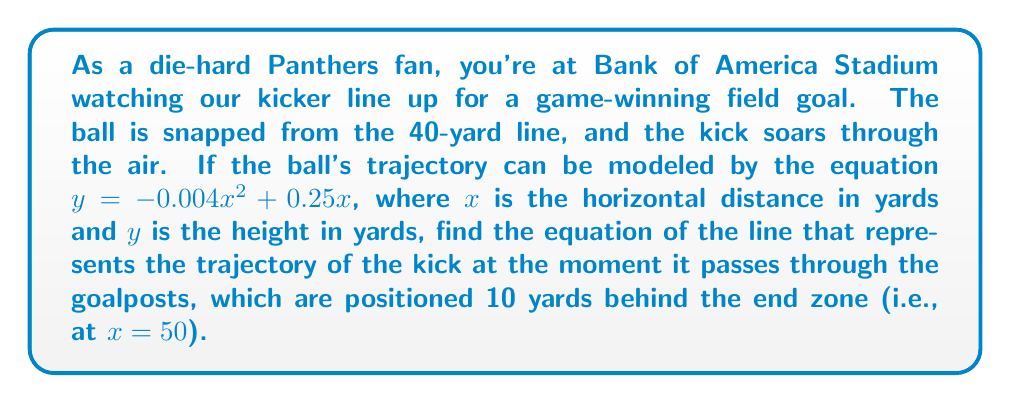Give your solution to this math problem. To find the equation of the line representing the trajectory at a specific point, we need to find the tangent line to the parabola at that point. Here's how we can do this:

1) First, let's find the coordinates of the point where the ball passes through the goalposts:
   At $x = 50$:
   $y = -0.004(50)^2 + 0.25(50) = -10 + 12.5 = 2.5$
   So, the point is $(50, 2.5)$

2) To find the slope of the tangent line, we need to find the derivative of the original function and evaluate it at $x = 50$:
   $f(x) = -0.004x^2 + 0.25x$
   $f'(x) = -0.008x + 0.25$
   At $x = 50$: $f'(50) = -0.008(50) + 0.25 = -0.15$

3) Now we have a point $(50, 2.5)$ and a slope $-0.15$. We can use the point-slope form of a line:
   $y - y_1 = m(x - x_1)$
   Where $(x_1, y_1)$ is our point and $m$ is our slope.

4) Substituting our values:
   $y - 2.5 = -0.15(x - 50)$

5) Simplify to slope-intercept form:
   $y = -0.15x + 7.5 + 2.5$
   $y = -0.15x + 10$

This is the equation of the line representing the trajectory of the kick as it passes through the goalposts.
Answer: $y = -0.15x + 10$ 